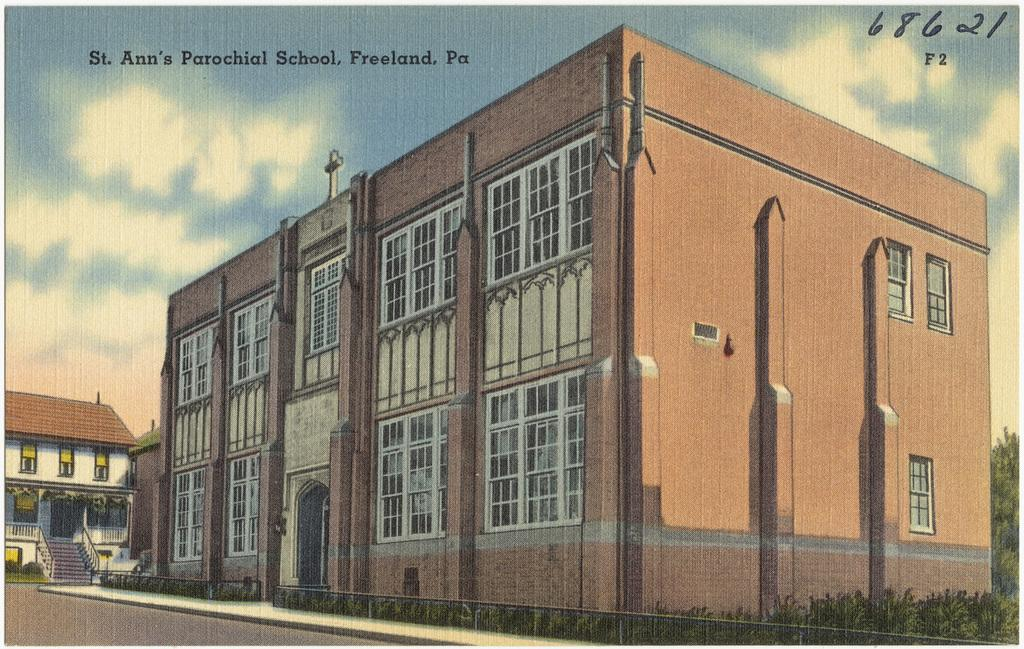<image>
Summarize the visual content of the image. St. Ann's Parochial School in Freeland, PA with number 68621 